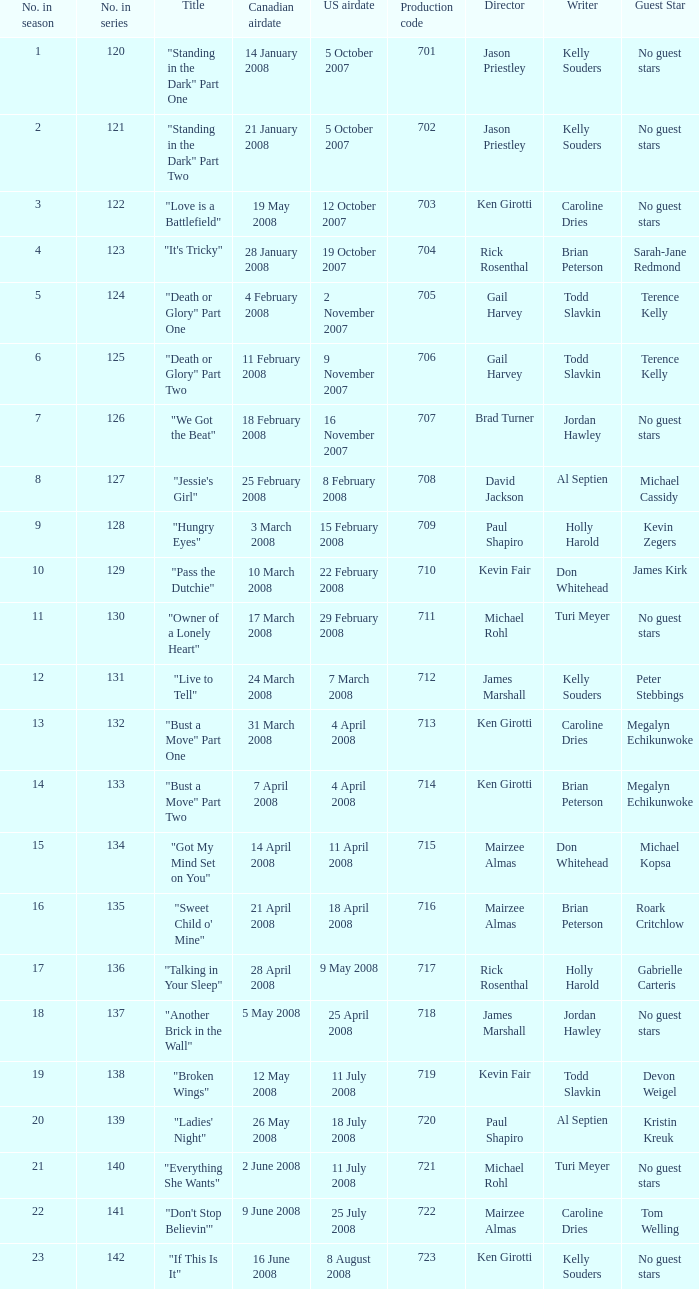The episode titled "don't stop believin'" was what highest number of the season? 22.0. 